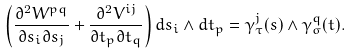<formula> <loc_0><loc_0><loc_500><loc_500>\left ( \frac { \partial ^ { 2 } W ^ { p q } } { \partial s _ { i } \partial s _ { j } } + \frac { \partial ^ { 2 } V ^ { i j } } { \partial t _ { p } \partial t _ { q } } \right ) d s _ { i } \wedge d t _ { p } = \gamma ^ { j } _ { \tau } ( s ) \wedge \gamma ^ { q } _ { \sigma } ( t ) .</formula> 